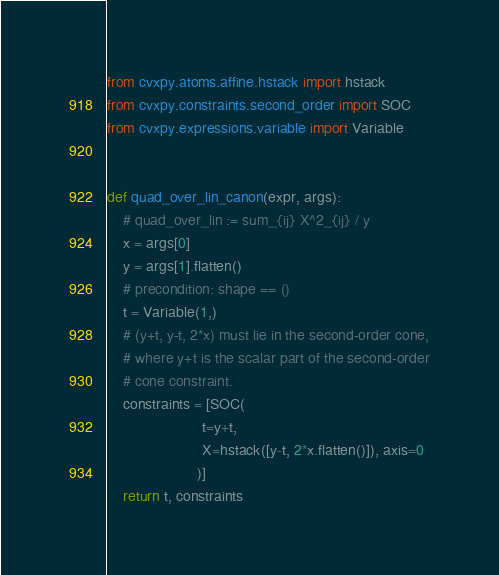Convert code to text. <code><loc_0><loc_0><loc_500><loc_500><_Python_>from cvxpy.atoms.affine.hstack import hstack
from cvxpy.constraints.second_order import SOC
from cvxpy.expressions.variable import Variable


def quad_over_lin_canon(expr, args):
    # quad_over_lin := sum_{ij} X^2_{ij} / y
    x = args[0]
    y = args[1].flatten()
    # precondition: shape == ()
    t = Variable(1,)
    # (y+t, y-t, 2*x) must lie in the second-order cone,
    # where y+t is the scalar part of the second-order
    # cone constraint.
    constraints = [SOC(
                       t=y+t,
                       X=hstack([y-t, 2*x.flatten()]), axis=0
                      )]
    return t, constraints
</code> 